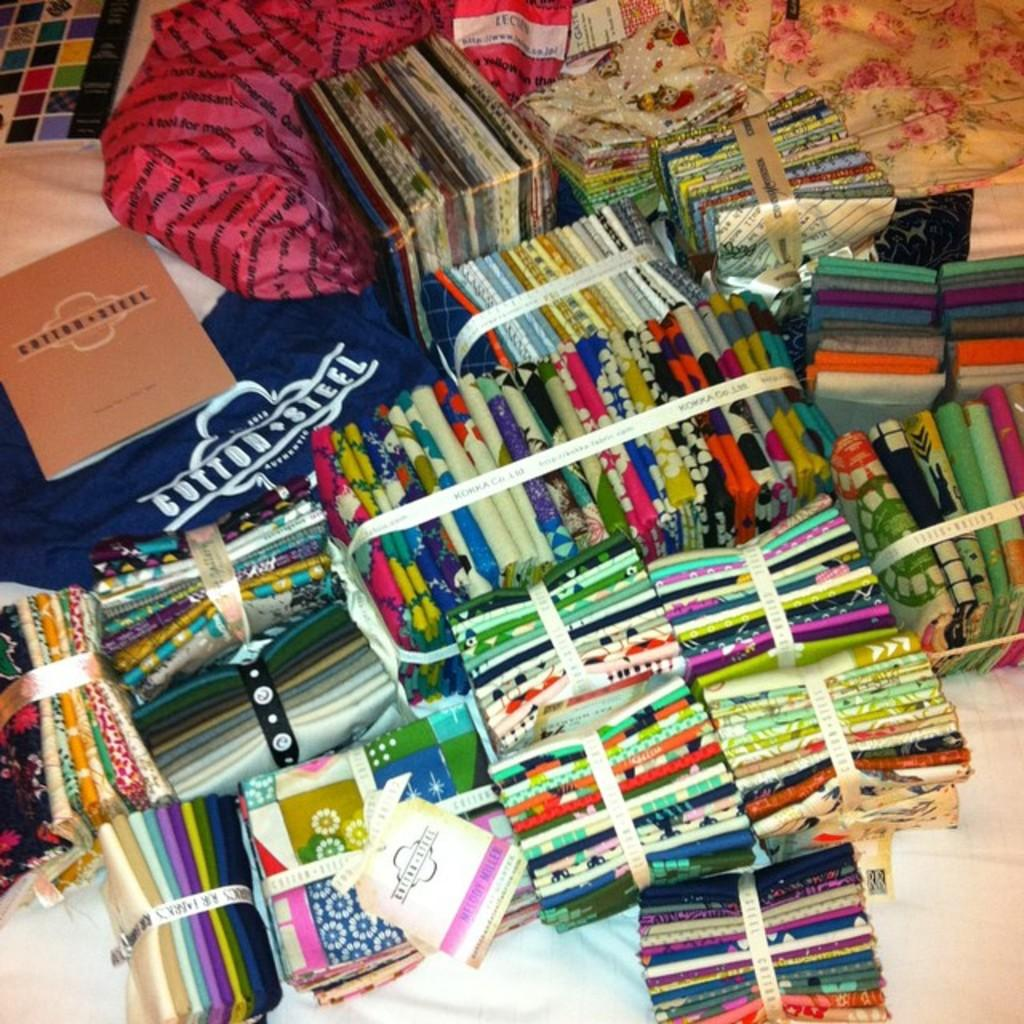<image>
Render a clear and concise summary of the photo. Bundled up clothing and a blue shirt that says Cotton Steel. 